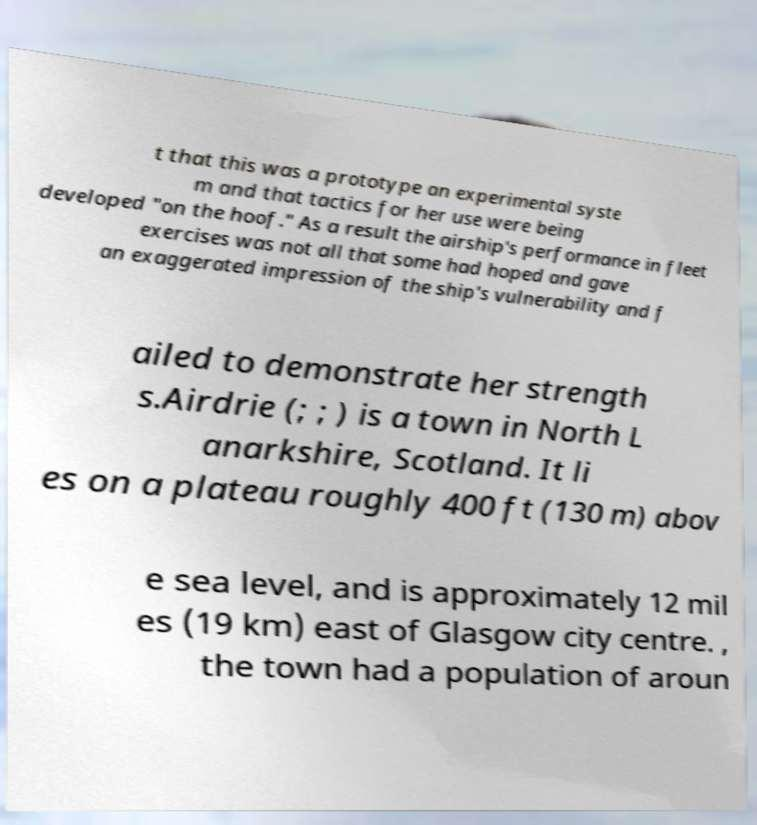Could you extract and type out the text from this image? t that this was a prototype an experimental syste m and that tactics for her use were being developed "on the hoof." As a result the airship's performance in fleet exercises was not all that some had hoped and gave an exaggerated impression of the ship's vulnerability and f ailed to demonstrate her strength s.Airdrie (; ; ) is a town in North L anarkshire, Scotland. It li es on a plateau roughly 400 ft (130 m) abov e sea level, and is approximately 12 mil es (19 km) east of Glasgow city centre. , the town had a population of aroun 